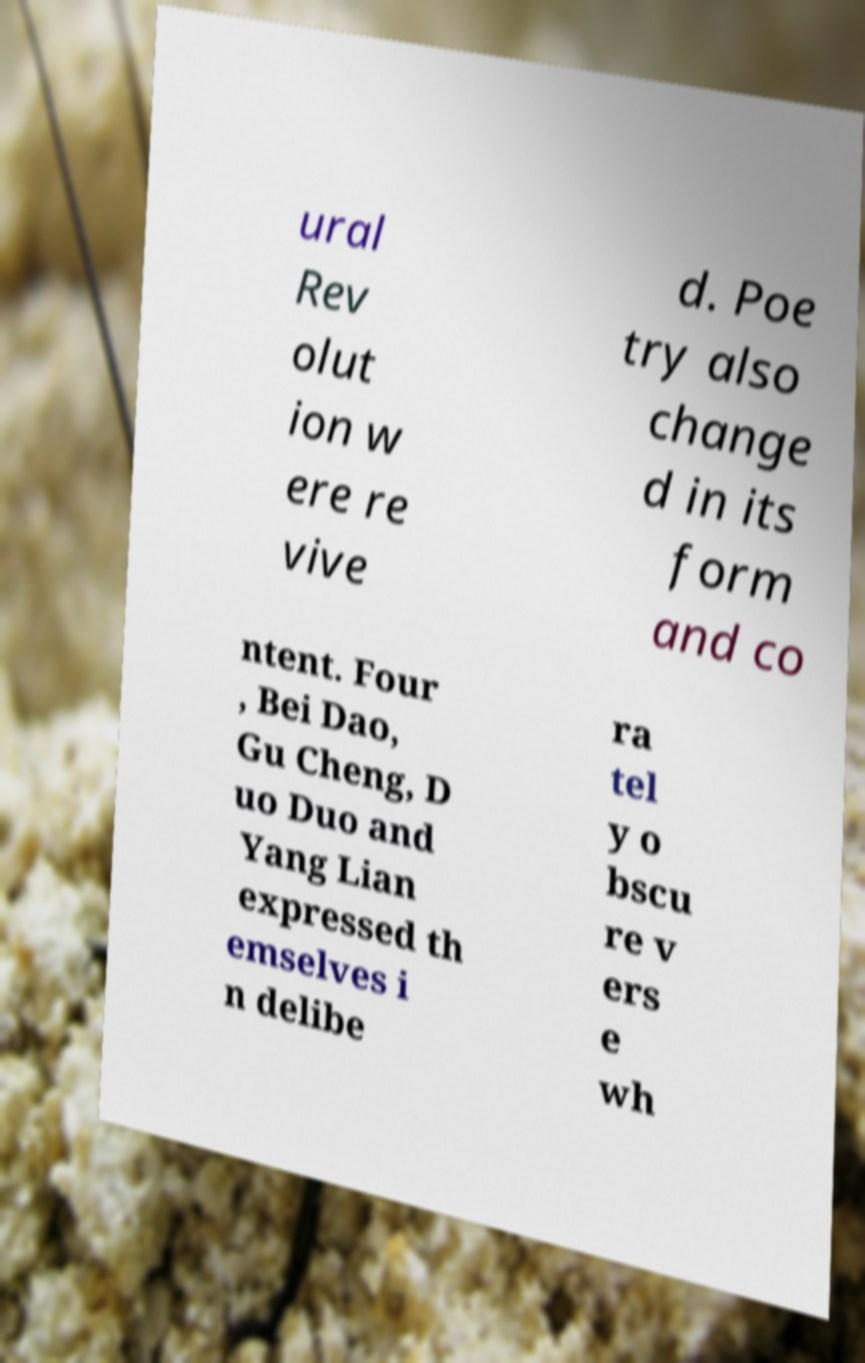There's text embedded in this image that I need extracted. Can you transcribe it verbatim? ural Rev olut ion w ere re vive d. Poe try also change d in its form and co ntent. Four , Bei Dao, Gu Cheng, D uo Duo and Yang Lian expressed th emselves i n delibe ra tel y o bscu re v ers e wh 